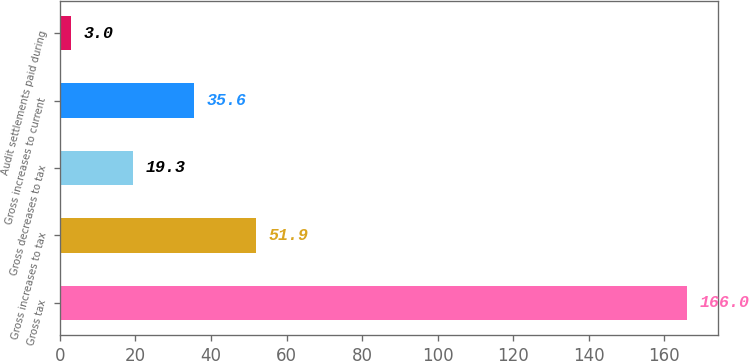Convert chart. <chart><loc_0><loc_0><loc_500><loc_500><bar_chart><fcel>Gross tax<fcel>Gross increases to tax<fcel>Gross decreases to tax<fcel>Gross increases to current<fcel>Audit settlements paid during<nl><fcel>166<fcel>51.9<fcel>19.3<fcel>35.6<fcel>3<nl></chart> 